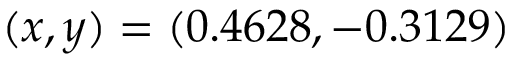Convert formula to latex. <formula><loc_0><loc_0><loc_500><loc_500>( x , y ) = ( 0 . 4 6 2 8 , - 0 . 3 1 2 9 )</formula> 